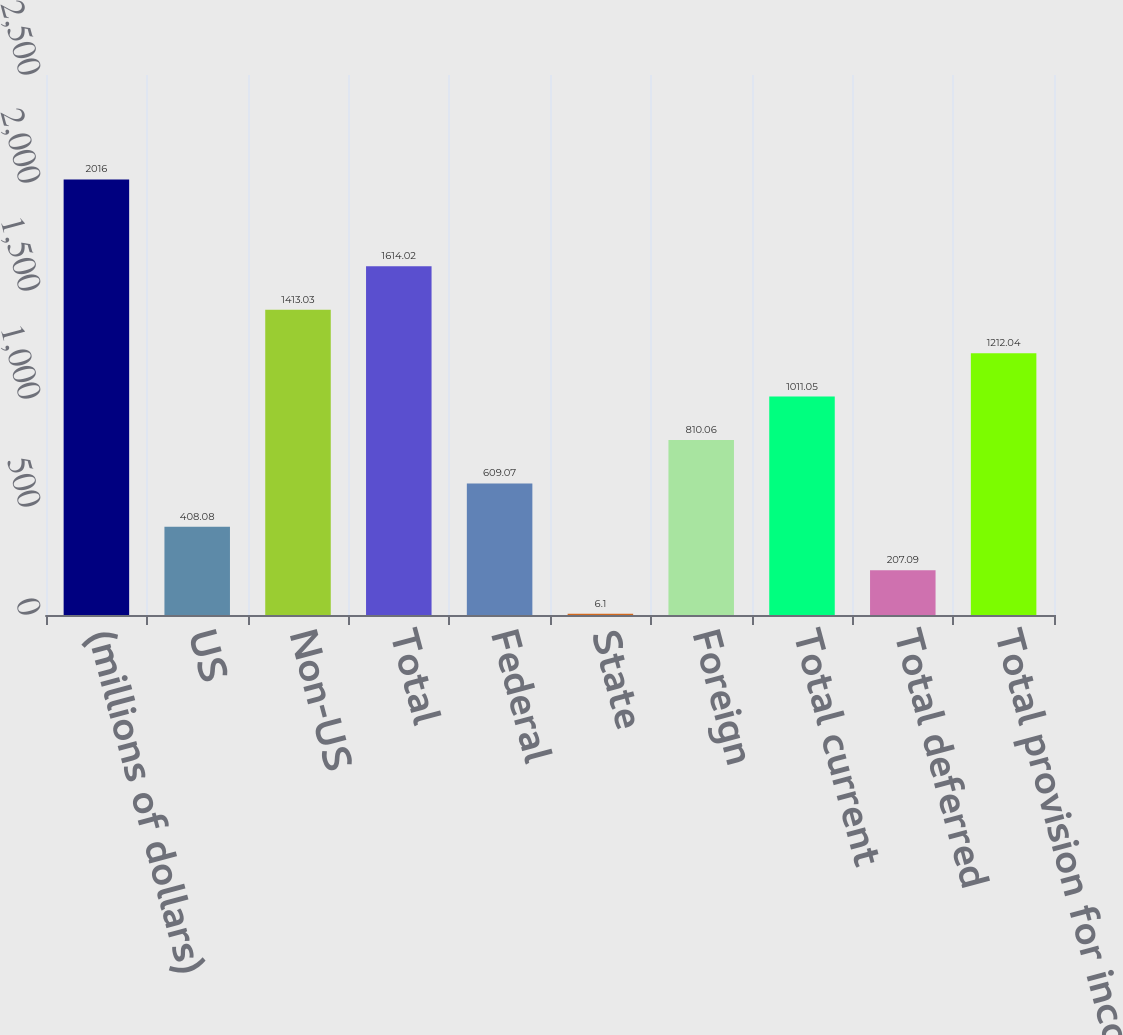<chart> <loc_0><loc_0><loc_500><loc_500><bar_chart><fcel>(millions of dollars)<fcel>US<fcel>Non-US<fcel>Total<fcel>Federal<fcel>State<fcel>Foreign<fcel>Total current<fcel>Total deferred<fcel>Total provision for income<nl><fcel>2016<fcel>408.08<fcel>1413.03<fcel>1614.02<fcel>609.07<fcel>6.1<fcel>810.06<fcel>1011.05<fcel>207.09<fcel>1212.04<nl></chart> 